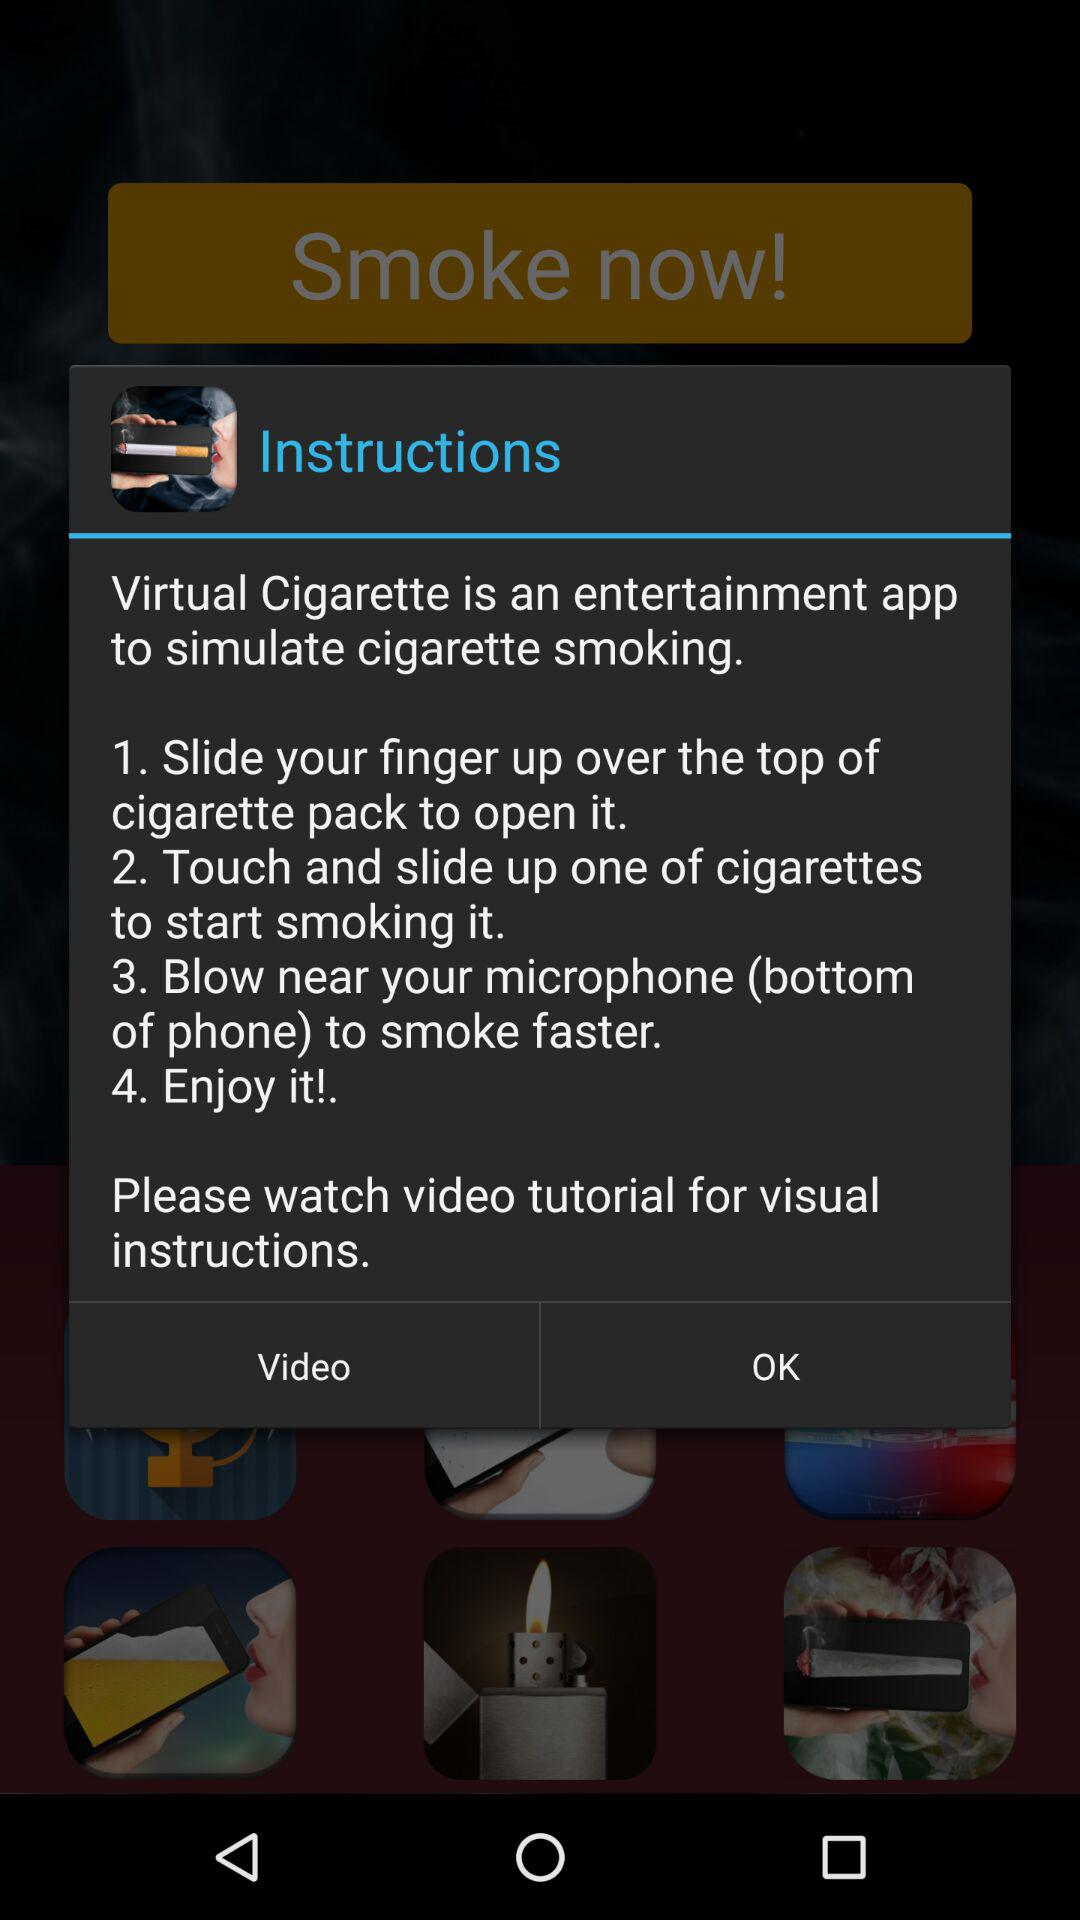How many steps are there in the instructions?
Answer the question using a single word or phrase. 4 